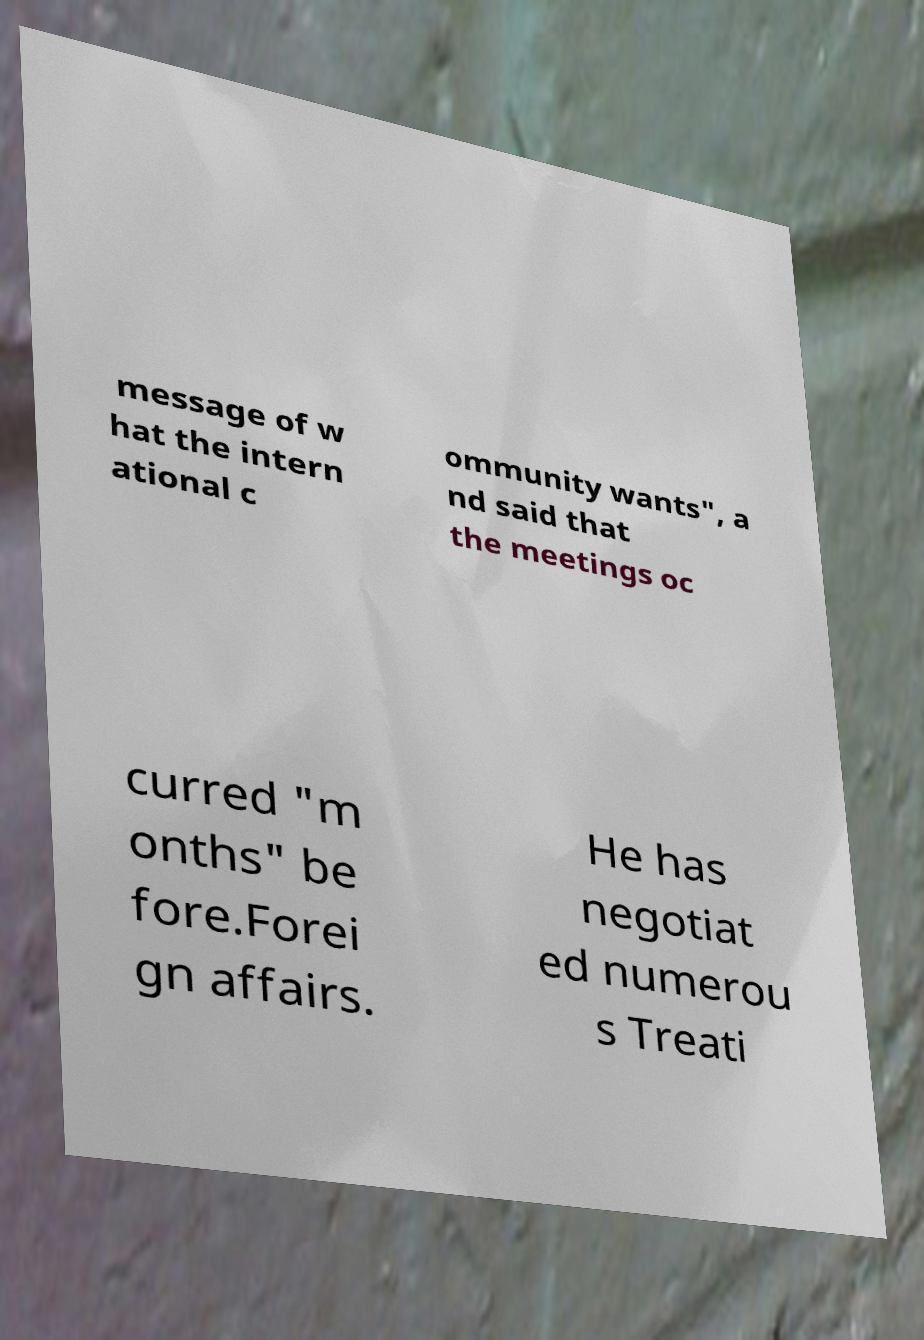Could you assist in decoding the text presented in this image and type it out clearly? message of w hat the intern ational c ommunity wants", a nd said that the meetings oc curred "m onths" be fore.Forei gn affairs. He has negotiat ed numerou s Treati 